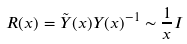<formula> <loc_0><loc_0><loc_500><loc_500>R ( x ) = \tilde { Y } ( x ) Y ( x ) ^ { - 1 } \sim \frac { 1 } { x } I</formula> 